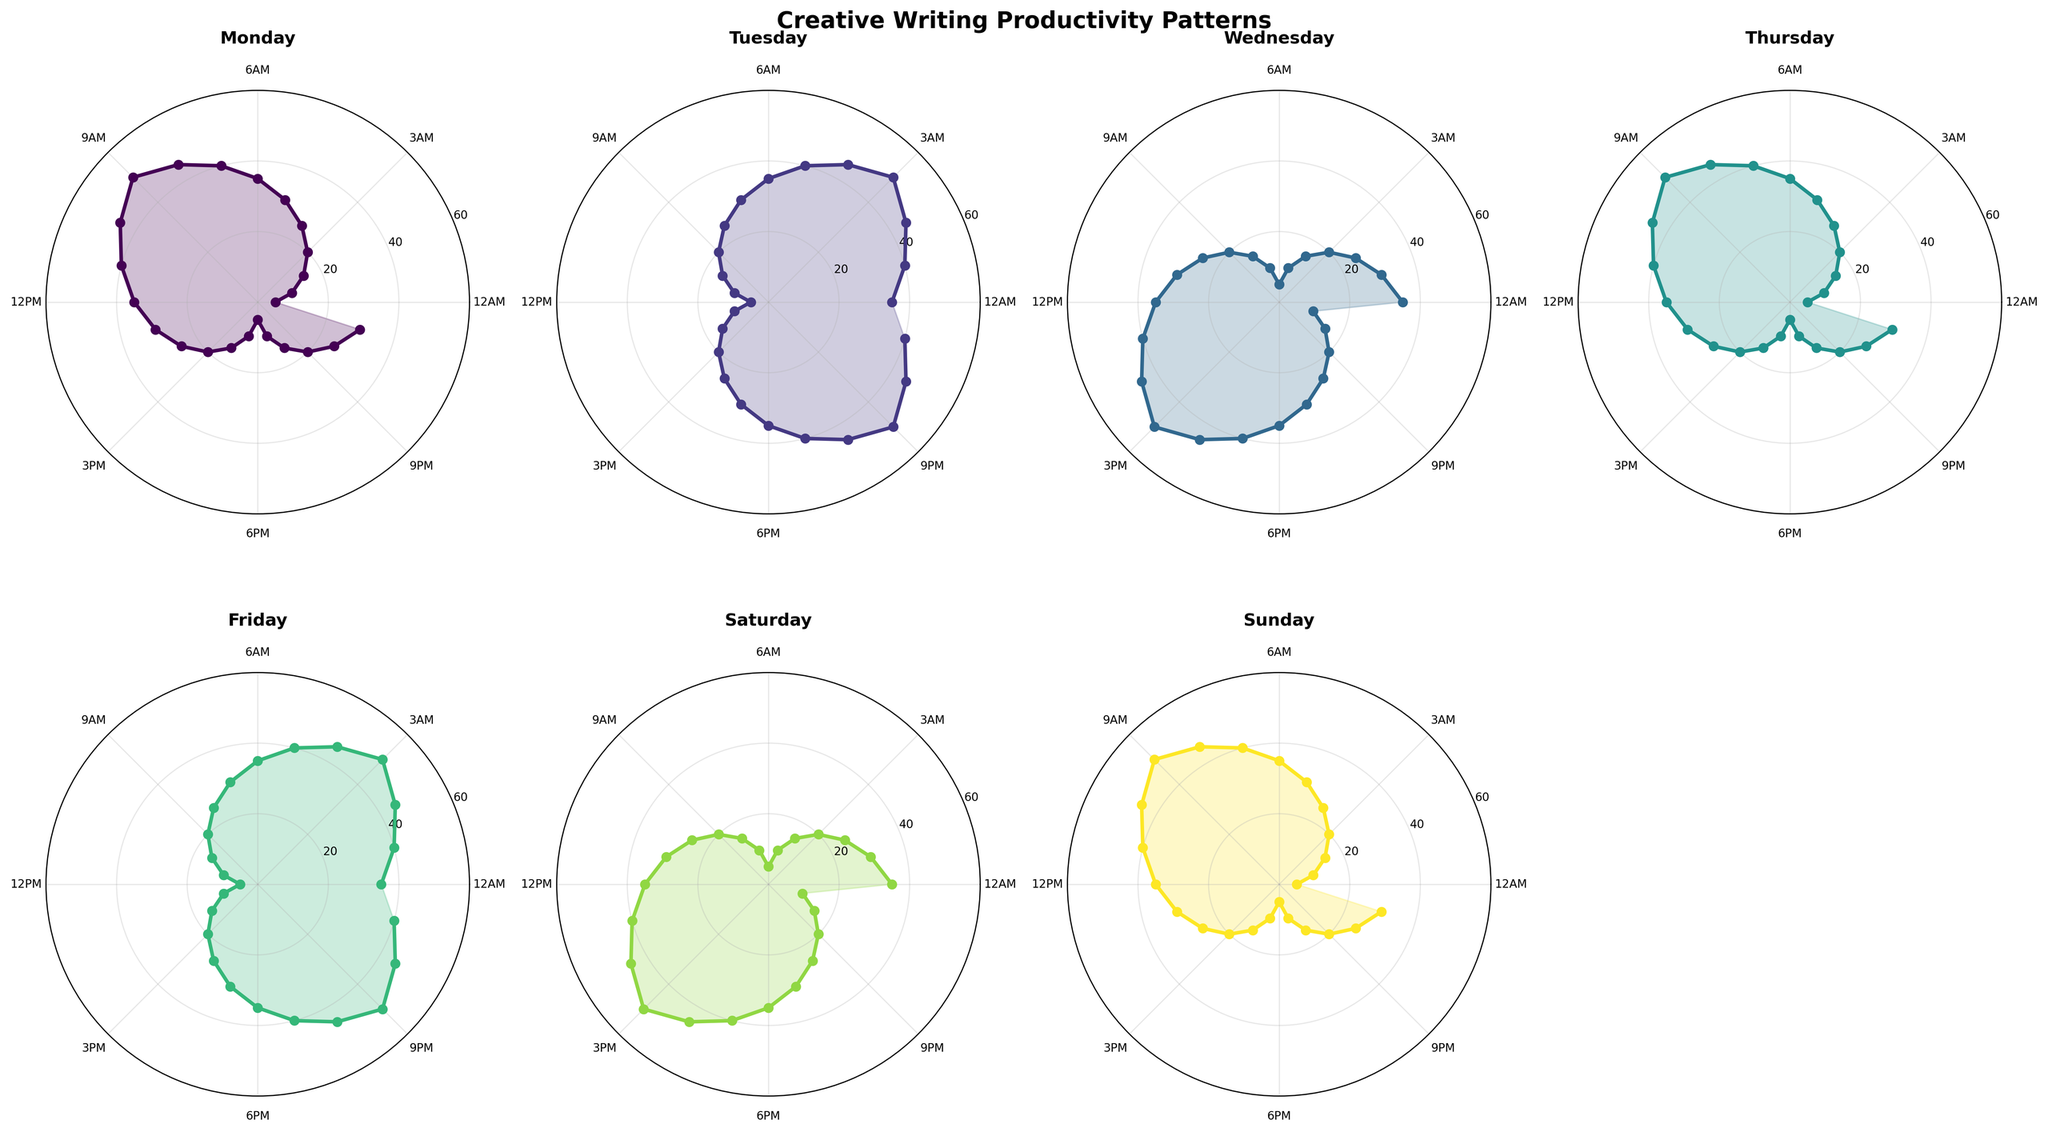What's the productivity level at 2 AM on Monday? Look for the 'Monday' subplot, find the 2 AM mark along the circular hour axis, and read the corresponding productivity level on the radius.
Answer: 15 Which day has the highest productivity at 9 AM? Compare the productivity levels at 9 AM for each of the subplots. For Monday, it's 50; for Tuesday, it's 20; for Wednesday, 20; Thursday, 50; Friday, 20; Saturday, 20; and Sunday, 50. Monday, Thursday, and Sunday all have the highest productivity at this hour.
Answer: Monday, Thursday, Sunday What is the average productivity level at 4 PM (16:00) across all days? Extract the productivity levels at 4 PM for each day and calculate the average. For Monday, it's 15; for Tuesday, 25; for Wednesday, 45; for Thursday, 15; for Friday, 25; for Saturday, 45; and for Sunday, 15. The average is (15 + 25 + 45 + 15 + 25 + 45 + 15) / 7 = 185 / 7 ≈ 26.43
Answer: 26.43 On which day is the productivity level consistently increasing from midnight to midday? Examine each subplot to observe a consistent increase in the radius values from midnight (0 AM) until midday (12 PM). On Tuesday, this increase is consistent.
Answer: Tuesday Which day shows the lowest productivity level at 10 PM (22:00)? Check the productivity level at 10 PM for each day. For Monday, it's 25; for Tuesday, 45; for Wednesday, 15; for Thursday, 25; for Friday, 45; for Saturday, 15; and for Sunday, 25. Wednesday and Saturday both have the lowest productivity level at this time.
Answer: Wednesday, Saturday Which two days have the most similar trends in productivity throughout the day? To find similar trends, look for days where the pattern of fluctuations and the levels of productivity overlay in a similar manner. Though various days may have overlaps, a detailed observation indicates that the trends for Wednesday and Saturday are closest in terms of their rises and falls throughout the day.
Answer: Wednesday, Saturday What's the peak productivity hour for Friday? Identify the highest point on the radius for the Friday subplot. The peak occurs at the point where the line reaches its maximum distance from the center. This happens at 3 AM (03:00).
Answer: 3 AM How does productivity change from morning (6:00 AM - 10:00 AM) to evening (6:00 PM - 10:00 PM) on Sunday? Compare the morning productivity levels (6 AM: 35, 7 AM: 40, 8 AM: 45, 9 AM: 50, 10 AM: 45) to the evening productivity levels (6 PM: 5, 7 PM: 10, 8 PM: 15, 9 PM: 20, 10 PM: 25) on the Sunday subplot. There is a noticeable decrease from high productivity in the morning to much lower levels in the evening.
Answer: Decreases Is there a day where productivity shows a "double peak" pattern throughout the day? Examine each day’s subplot to find one that has two notable peaks in productivity levels. Notably, Wednesday and Saturday both show peaks around 9 AM and another around 3 PM.
Answer: Wednesday, Saturday 